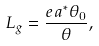<formula> <loc_0><loc_0><loc_500><loc_500>L _ { g } = \frac { e a ^ { * } \theta _ { 0 } } { \theta } ,</formula> 